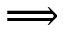<formula> <loc_0><loc_0><loc_500><loc_500>\Longrightarrow</formula> 